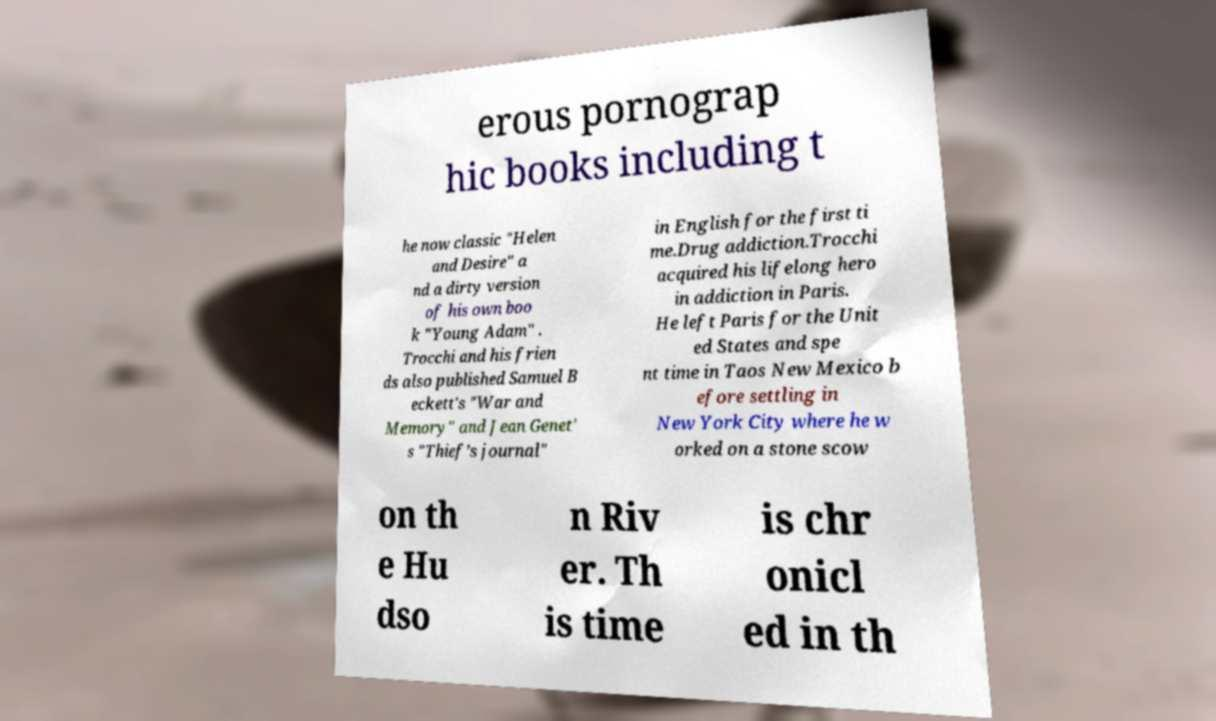Please identify and transcribe the text found in this image. erous pornograp hic books including t he now classic "Helen and Desire" a nd a dirty version of his own boo k "Young Adam" . Trocchi and his frien ds also published Samuel B eckett's "War and Memory" and Jean Genet' s "Thief’s journal" in English for the first ti me.Drug addiction.Trocchi acquired his lifelong hero in addiction in Paris. He left Paris for the Unit ed States and spe nt time in Taos New Mexico b efore settling in New York City where he w orked on a stone scow on th e Hu dso n Riv er. Th is time is chr onicl ed in th 